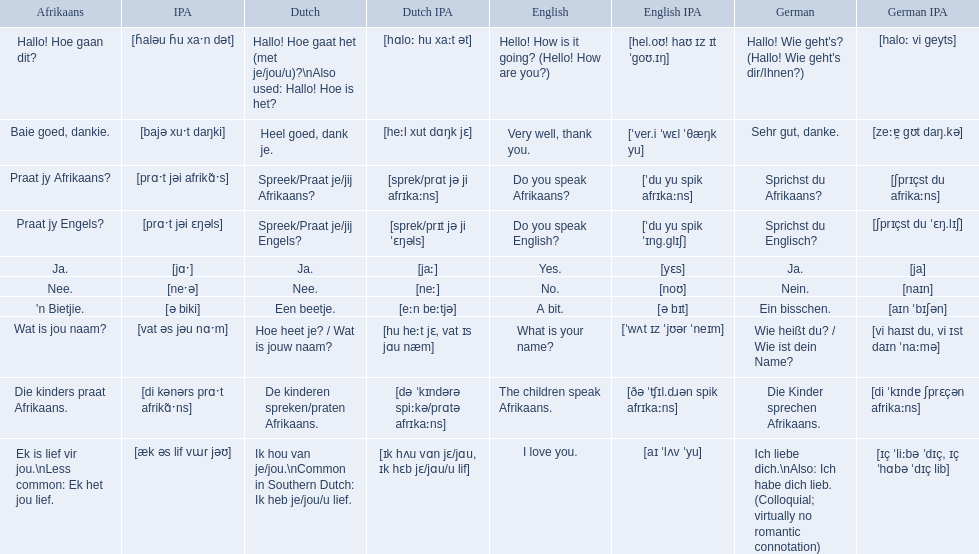What are all of the afrikaans phrases in the list? Hallo! Hoe gaan dit?, Baie goed, dankie., Praat jy Afrikaans?, Praat jy Engels?, Ja., Nee., 'n Bietjie., Wat is jou naam?, Die kinders praat Afrikaans., Ek is lief vir jou.\nLess common: Ek het jou lief. What is the english translation of each phrase? Hello! How is it going? (Hello! How are you?), Very well, thank you., Do you speak Afrikaans?, Do you speak English?, Yes., No., A bit., What is your name?, The children speak Afrikaans., I love you. And which afrikaans phrase translated to do you speak afrikaans? Praat jy Afrikaans?. 